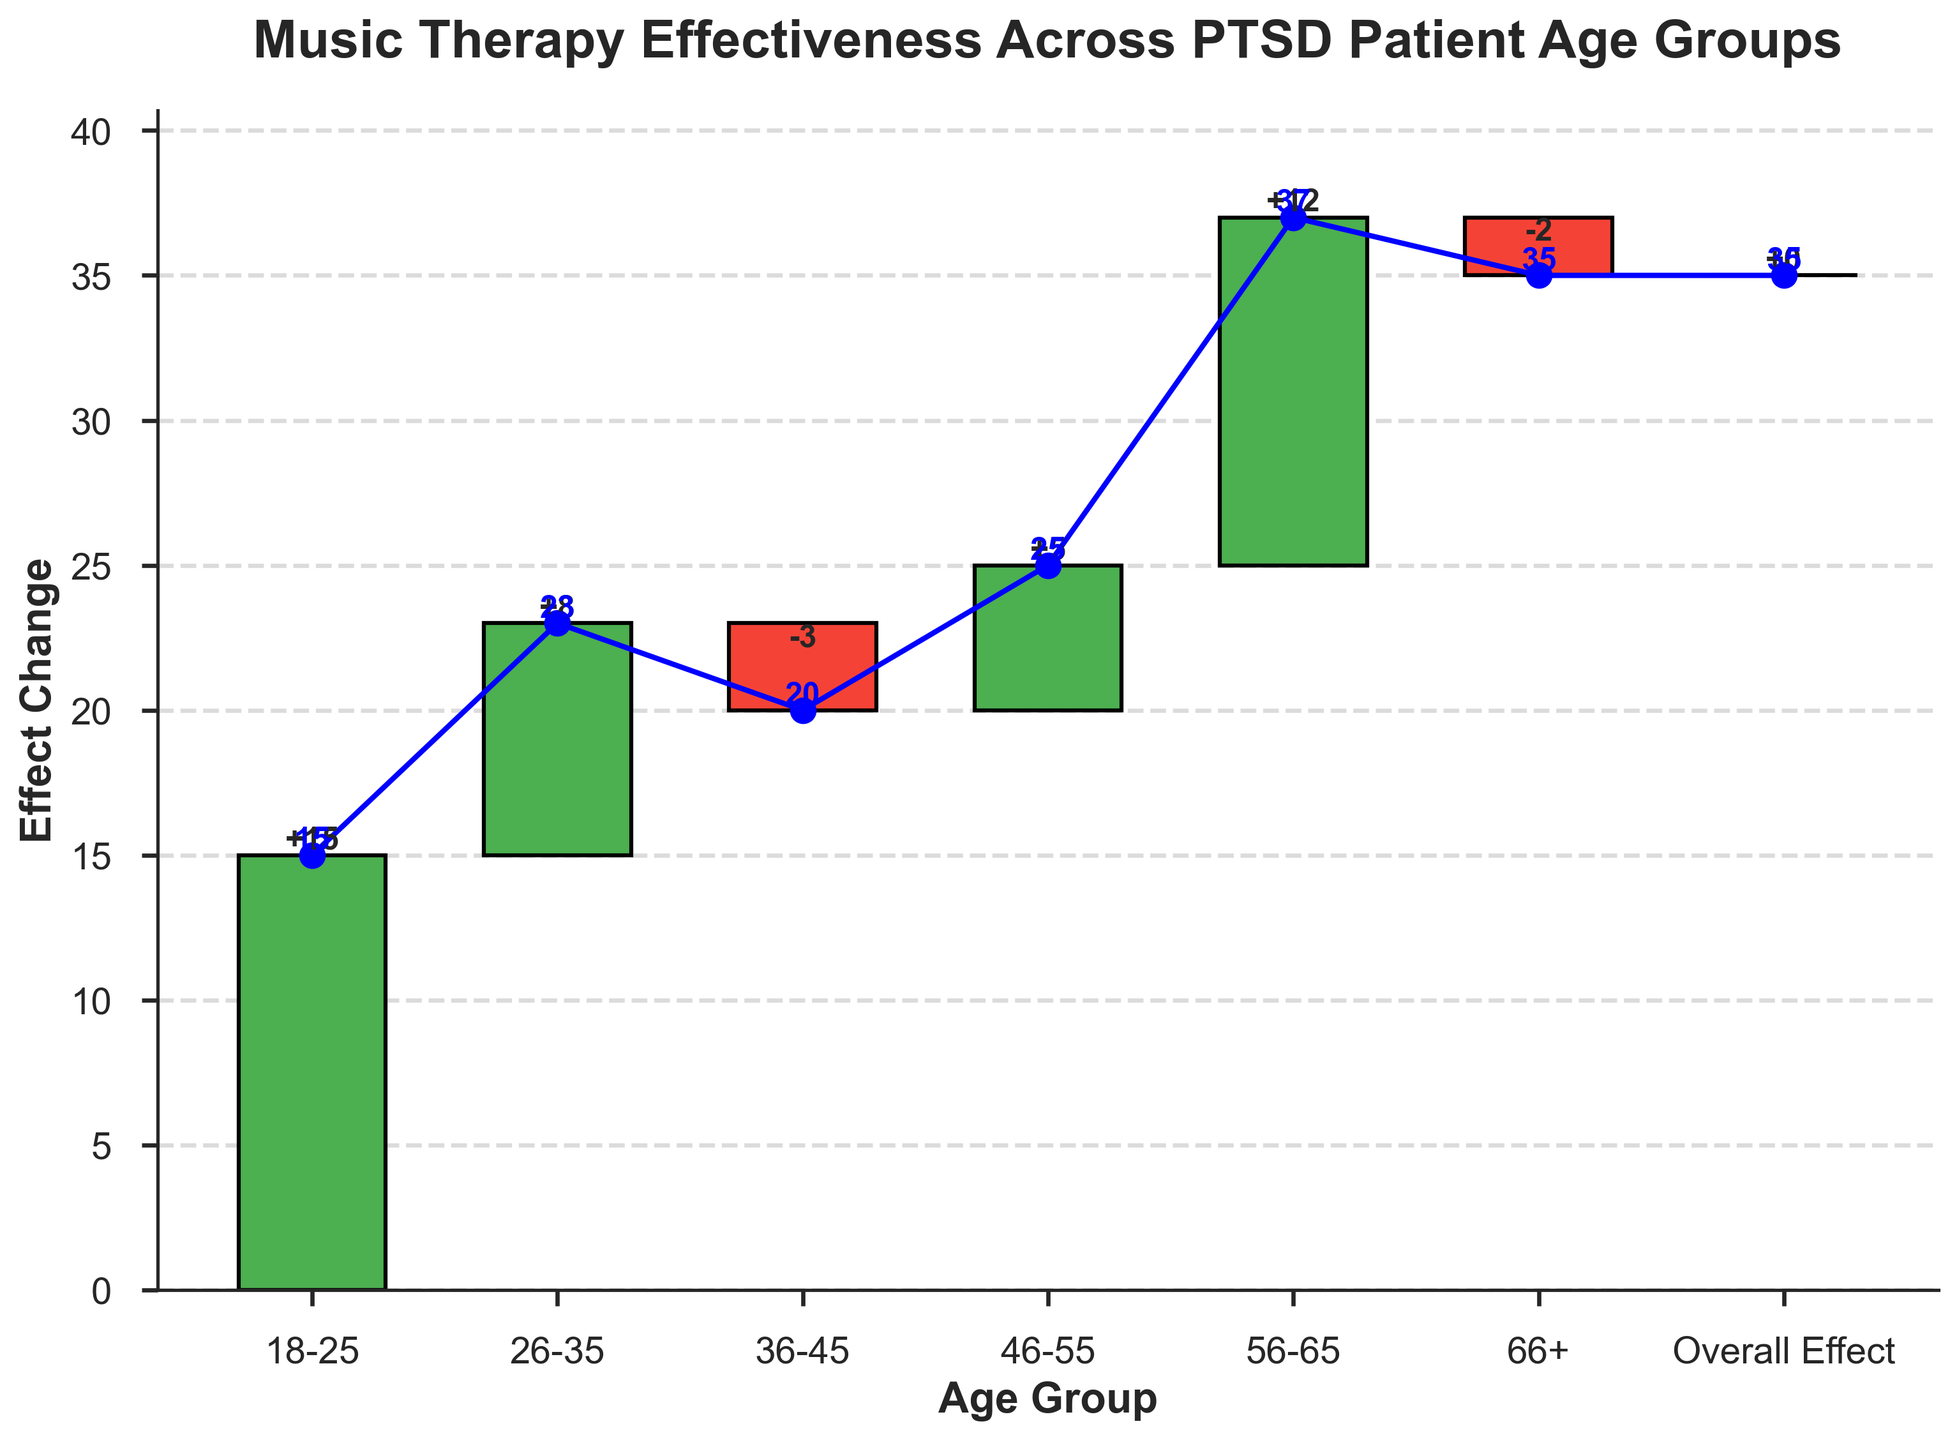How many age groups are included in the figure? The figure has bars for the age groups "18-25", "26-35", "36-45", "46-55", "56-65", and "66+", giving a total of 6 age groups.
Answer: 6 What is the overall effect change across all age groups? The overall effect change is indicated at the last bar labeled "Overall Effect," which has an effect change of 0.
Answer: 0 Which age group has the highest positive effect change? The highest positive effect change is from the "56-65" age group with an effect change of +12, visible from the height of the bar.
Answer: 56-65 How does the cumulative effect change from the "36-45" age group to the "46-55" age group? The cumulative effect goes from 20 for the "36-45" age group to 25 for the "46-55" age group, indicating an increase of 5.
Answer: It increases by 5 What is the effect change of the "66+" age group? The "66+" age group has an effect change of -2, indicated by the bar going down and being labeled with -2.
Answer: -2 Which age group has the lowest positive or highest negative effect change? The "36-45" age group has a negative effect change of -3, which is the lowest or most negative change.
Answer: 36-45 What is the cumulative effect for the "26-35" age group? For the "26-35" age group, the cumulative effect is given as 23, visible at the top of the corresponding cumulative plot point and labeled number next to it.
Answer: 23 Compare the effect change between the "18-25" and the "56-65" age groups. The effect change for "18-25" is +15, and for "56-65" it is +12. Comparing these, the "18-25" group has a greater effect change by 3 units.
Answer: "18-25" is higher by 3 What is the total cumulative effect across all age groups? The final cumulative effect is visible at the "Overall Effect" which shows a cumulative effect of 35.
Answer: 35 Is the overall effect positive, negative, or neutral? The overall effect, seen at the "Overall Effect" bar, is 0 which indicates it is neutral.
Answer: neutral 